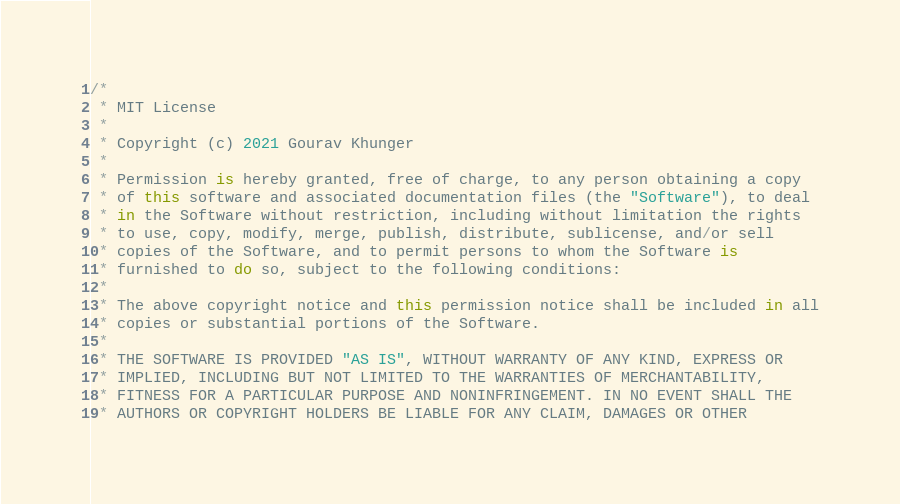Convert code to text. <code><loc_0><loc_0><loc_500><loc_500><_Kotlin_>/*
 * MIT License
 *
 * Copyright (c) 2021 Gourav Khunger
 *
 * Permission is hereby granted, free of charge, to any person obtaining a copy
 * of this software and associated documentation files (the "Software"), to deal
 * in the Software without restriction, including without limitation the rights
 * to use, copy, modify, merge, publish, distribute, sublicense, and/or sell
 * copies of the Software, and to permit persons to whom the Software is
 * furnished to do so, subject to the following conditions:
 *
 * The above copyright notice and this permission notice shall be included in all
 * copies or substantial portions of the Software.
 *
 * THE SOFTWARE IS PROVIDED "AS IS", WITHOUT WARRANTY OF ANY KIND, EXPRESS OR
 * IMPLIED, INCLUDING BUT NOT LIMITED TO THE WARRANTIES OF MERCHANTABILITY,
 * FITNESS FOR A PARTICULAR PURPOSE AND NONINFRINGEMENT. IN NO EVENT SHALL THE
 * AUTHORS OR COPYRIGHT HOLDERS BE LIABLE FOR ANY CLAIM, DAMAGES OR OTHER</code> 